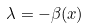Convert formula to latex. <formula><loc_0><loc_0><loc_500><loc_500>\lambda = - \beta ( x )</formula> 